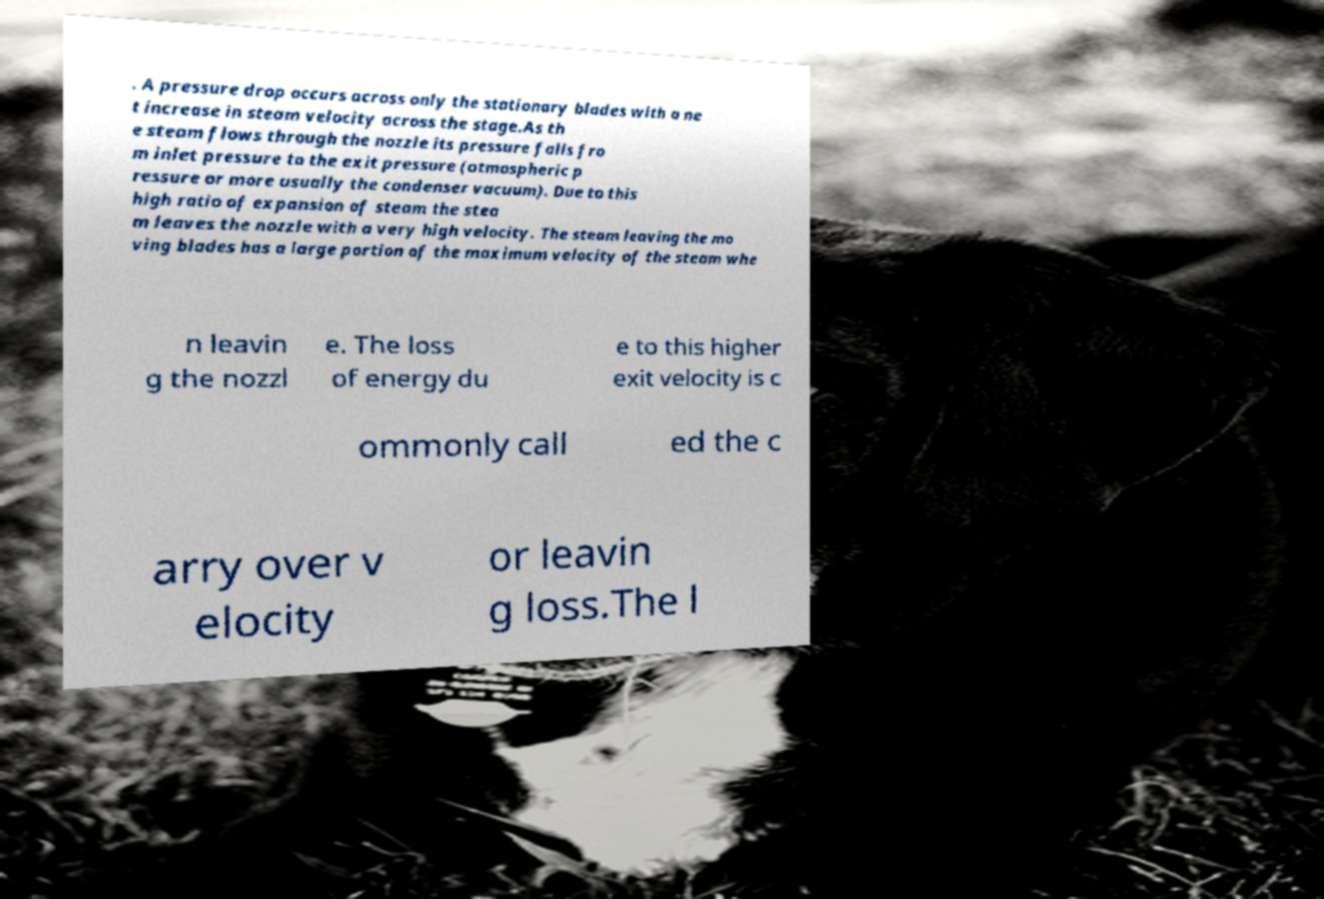Please identify and transcribe the text found in this image. . A pressure drop occurs across only the stationary blades with a ne t increase in steam velocity across the stage.As th e steam flows through the nozzle its pressure falls fro m inlet pressure to the exit pressure (atmospheric p ressure or more usually the condenser vacuum). Due to this high ratio of expansion of steam the stea m leaves the nozzle with a very high velocity. The steam leaving the mo ving blades has a large portion of the maximum velocity of the steam whe n leavin g the nozzl e. The loss of energy du e to this higher exit velocity is c ommonly call ed the c arry over v elocity or leavin g loss.The l 